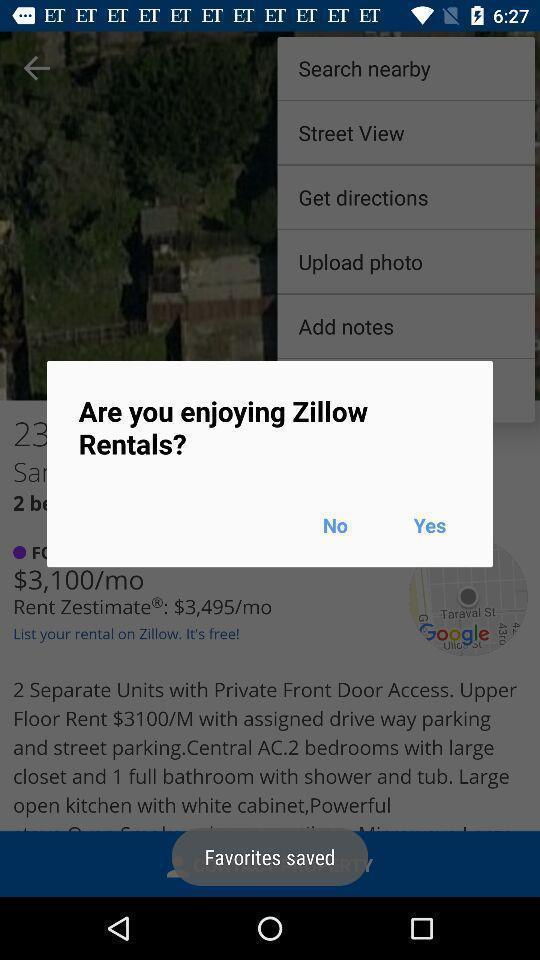Describe the content in this image. Popup of question regarding satisfactory of rentals in the application. 